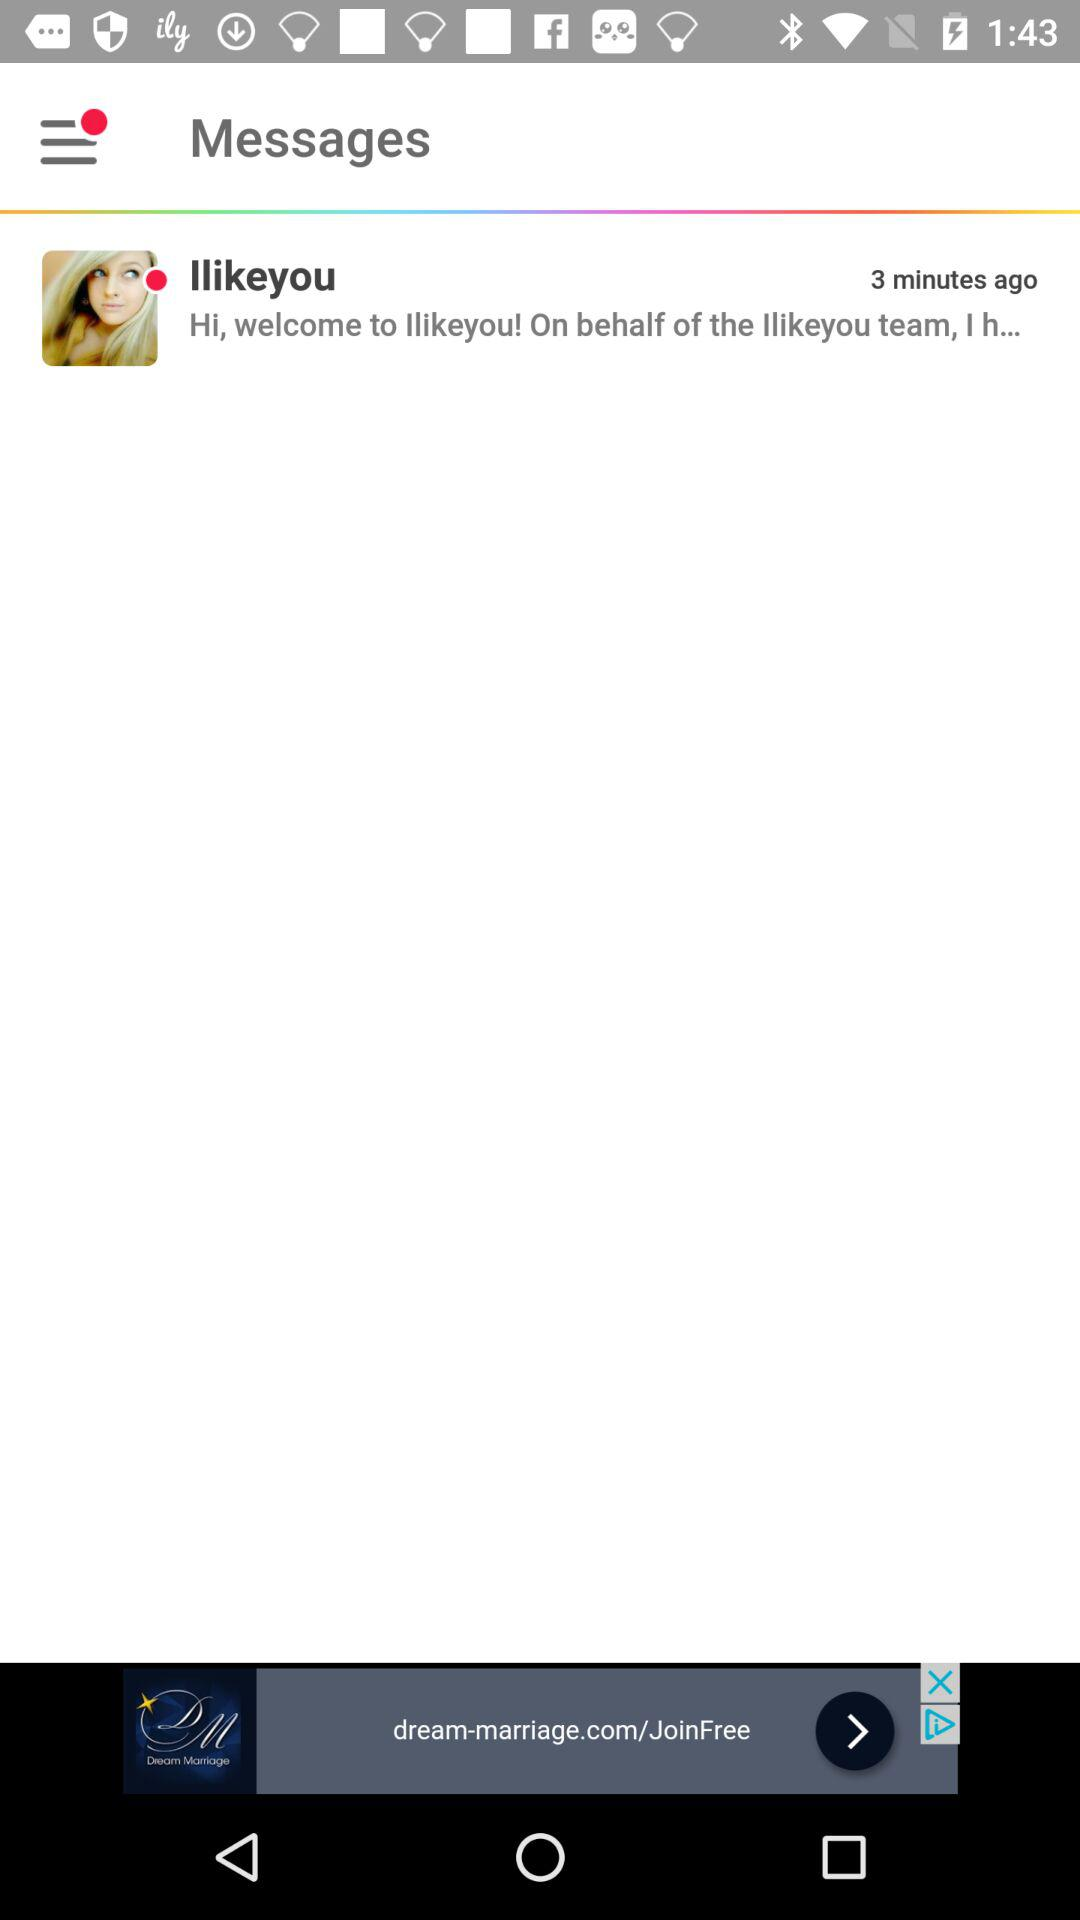How many minutes ago was the message received? The message was received 3 minutes ago. 